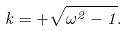<formula> <loc_0><loc_0><loc_500><loc_500>k = + \sqrt { \omega ^ { 2 } - 1 } .</formula> 